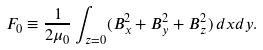<formula> <loc_0><loc_0><loc_500><loc_500>F _ { 0 } \equiv \frac { 1 } { 2 \mu _ { 0 } } \int _ { z = 0 } ( B _ { x } ^ { 2 } + B _ { y } ^ { 2 } + B _ { z } ^ { 2 } ) \, d x d y .</formula> 